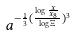<formula> <loc_0><loc_0><loc_500><loc_500>a ^ { - \frac { 1 } { 3 } ( \frac { \log \frac { x } { x _ { 8 } } } { \log \Xi } ) ^ { 3 } }</formula> 